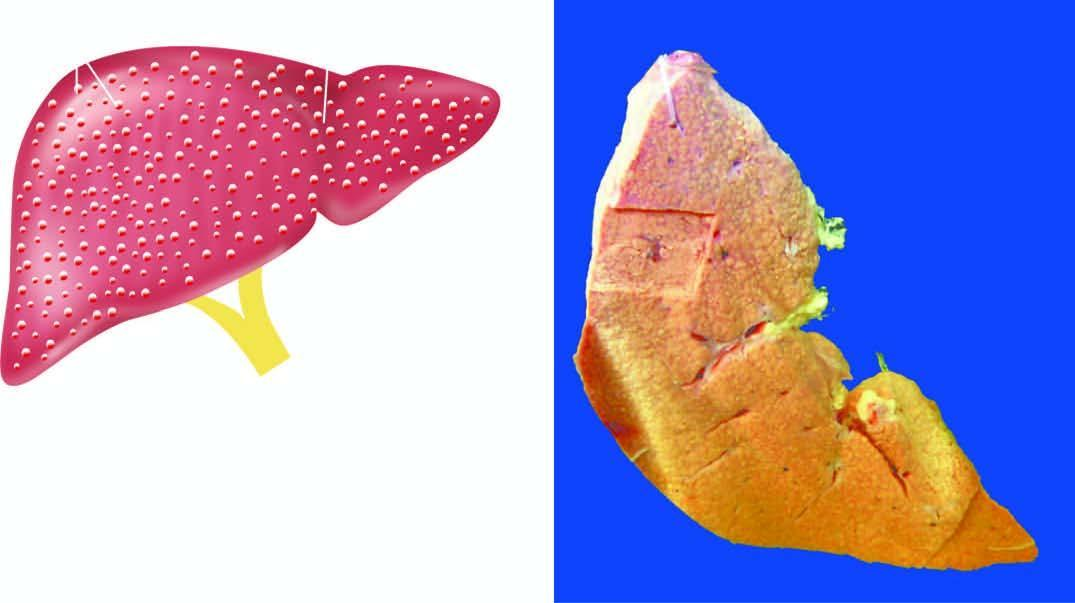s there diffuse nodularity on sectioned surface of the liver?
Answer the question using a single word or phrase. Yes 